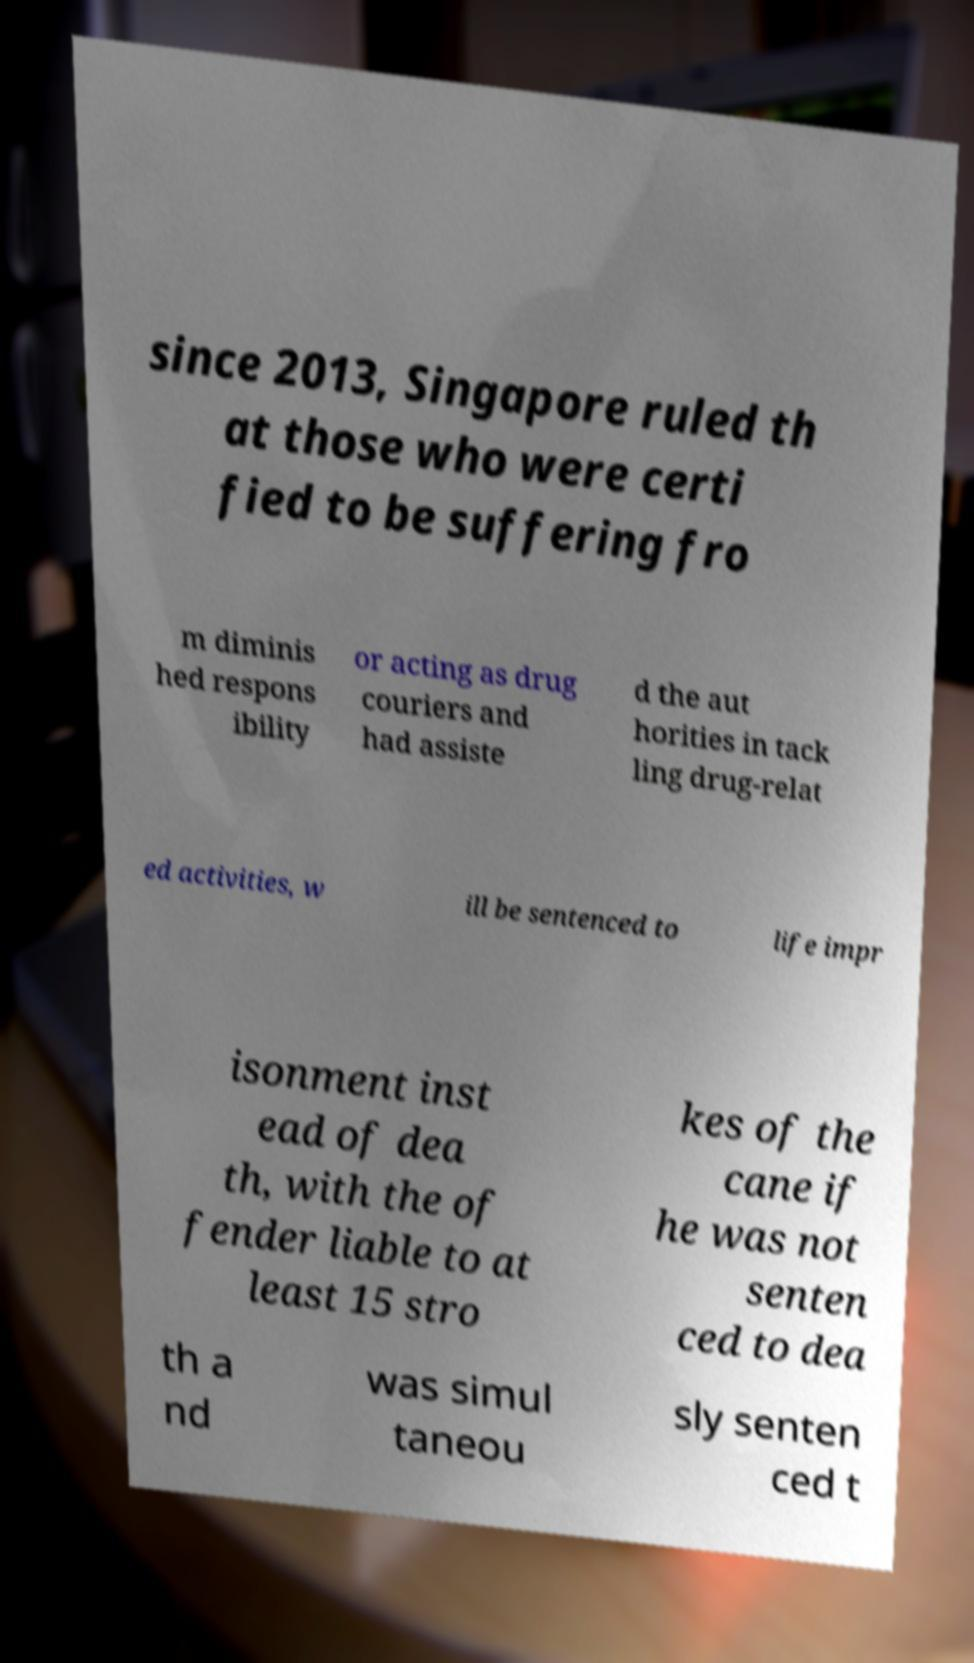Could you assist in decoding the text presented in this image and type it out clearly? since 2013, Singapore ruled th at those who were certi fied to be suffering fro m diminis hed respons ibility or acting as drug couriers and had assiste d the aut horities in tack ling drug-relat ed activities, w ill be sentenced to life impr isonment inst ead of dea th, with the of fender liable to at least 15 stro kes of the cane if he was not senten ced to dea th a nd was simul taneou sly senten ced t 